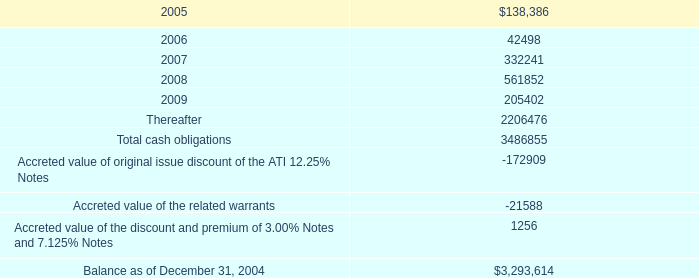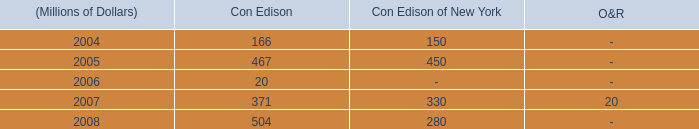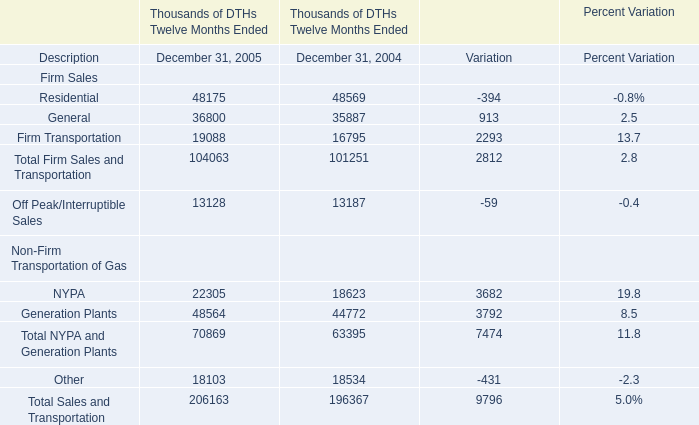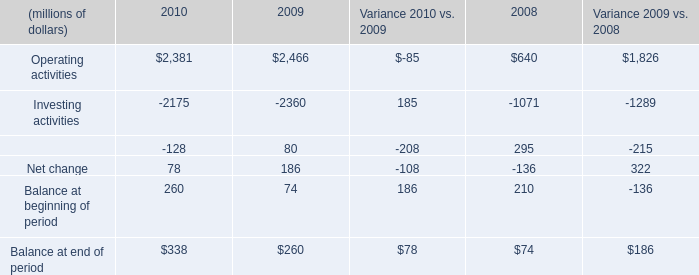What will firm transportation be like in 2016 if it develops with the same increasing rate as current? 
Computations: ((((19088 - 16795) / 16795) + 1) * 19088)
Answer: 21694.06038. 